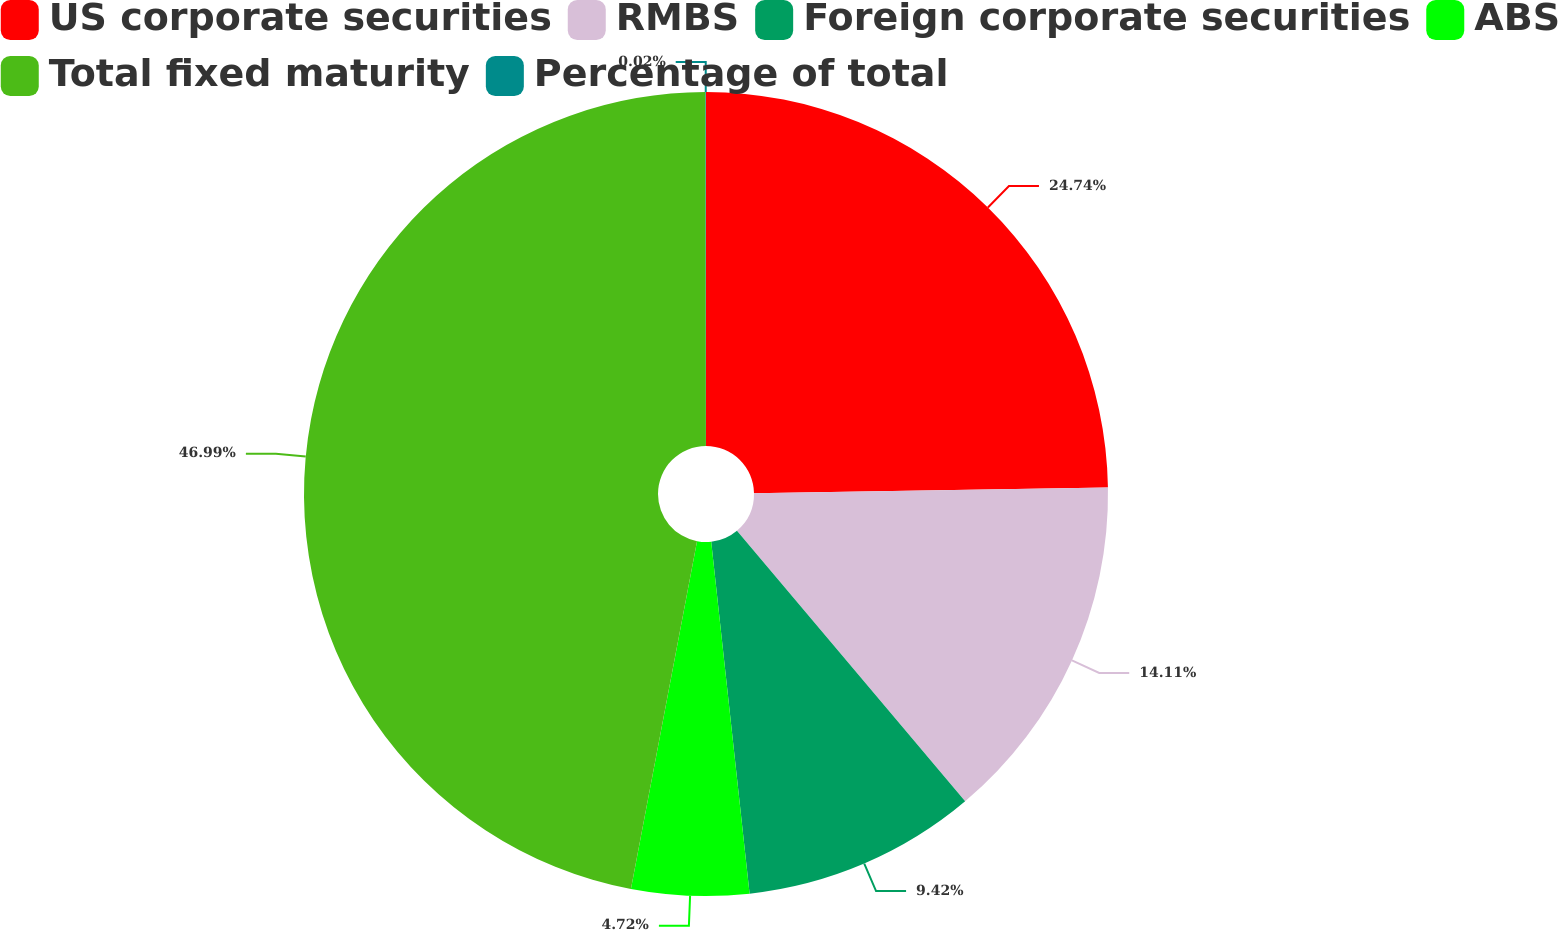Convert chart. <chart><loc_0><loc_0><loc_500><loc_500><pie_chart><fcel>US corporate securities<fcel>RMBS<fcel>Foreign corporate securities<fcel>ABS<fcel>Total fixed maturity<fcel>Percentage of total<nl><fcel>24.74%<fcel>14.11%<fcel>9.42%<fcel>4.72%<fcel>46.99%<fcel>0.02%<nl></chart> 